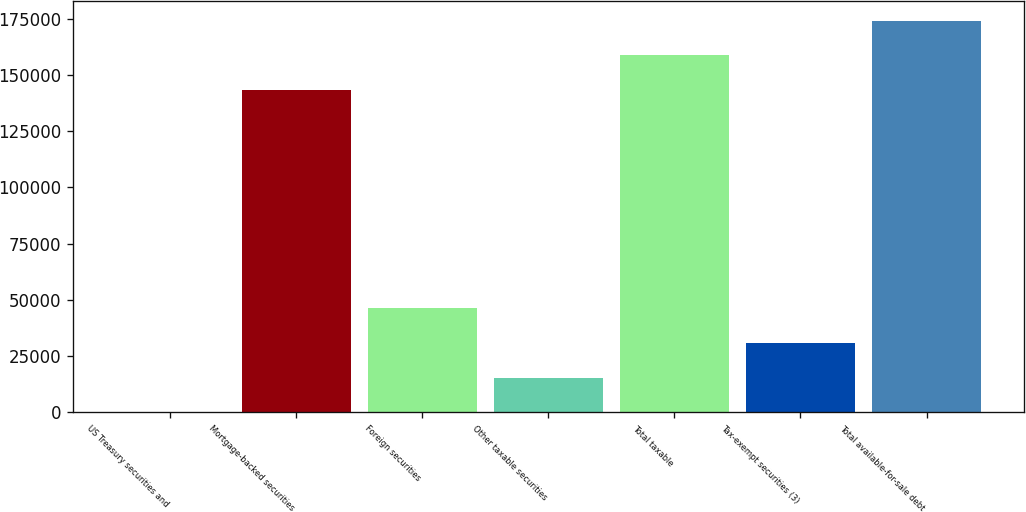Convert chart to OTSL. <chart><loc_0><loc_0><loc_500><loc_500><bar_chart><fcel>US Treasury securities and<fcel>Mortgage-backed securities<fcel>Foreign securities<fcel>Other taxable securities<fcel>Total taxable<fcel>Tax-exempt securities (3)<fcel>Total available-for-sale debt<nl><fcel>80<fcel>143370<fcel>46214.6<fcel>15458.2<fcel>158748<fcel>30836.4<fcel>174126<nl></chart> 